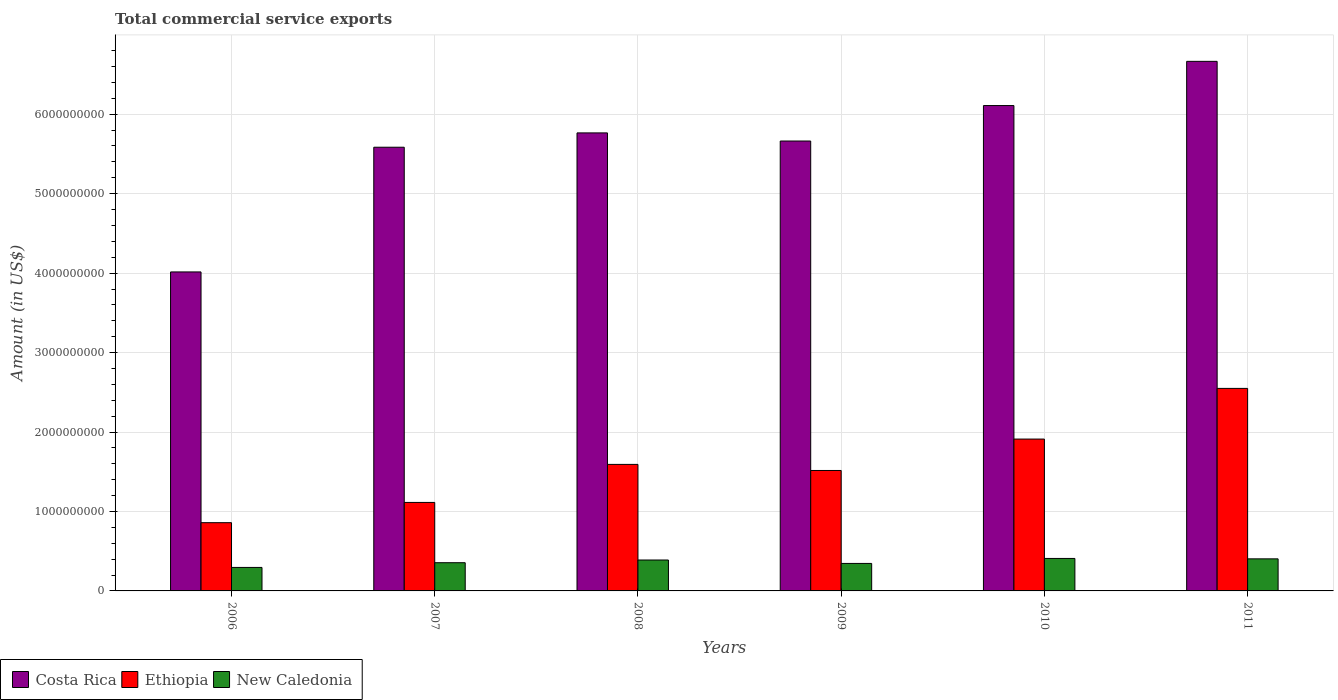How many different coloured bars are there?
Offer a terse response. 3. How many groups of bars are there?
Your response must be concise. 6. How many bars are there on the 4th tick from the left?
Make the answer very short. 3. How many bars are there on the 4th tick from the right?
Your response must be concise. 3. What is the label of the 4th group of bars from the left?
Make the answer very short. 2009. What is the total commercial service exports in Ethiopia in 2011?
Provide a short and direct response. 2.55e+09. Across all years, what is the maximum total commercial service exports in Costa Rica?
Offer a terse response. 6.67e+09. Across all years, what is the minimum total commercial service exports in Costa Rica?
Your answer should be compact. 4.01e+09. In which year was the total commercial service exports in New Caledonia maximum?
Provide a succinct answer. 2010. In which year was the total commercial service exports in Costa Rica minimum?
Keep it short and to the point. 2006. What is the total total commercial service exports in Costa Rica in the graph?
Provide a succinct answer. 3.38e+1. What is the difference between the total commercial service exports in Ethiopia in 2008 and that in 2009?
Provide a short and direct response. 7.64e+07. What is the difference between the total commercial service exports in Costa Rica in 2007 and the total commercial service exports in Ethiopia in 2009?
Provide a short and direct response. 4.07e+09. What is the average total commercial service exports in Costa Rica per year?
Offer a very short reply. 5.63e+09. In the year 2010, what is the difference between the total commercial service exports in New Caledonia and total commercial service exports in Costa Rica?
Provide a succinct answer. -5.70e+09. In how many years, is the total commercial service exports in Ethiopia greater than 400000000 US$?
Provide a succinct answer. 6. What is the ratio of the total commercial service exports in New Caledonia in 2008 to that in 2011?
Give a very brief answer. 0.96. Is the difference between the total commercial service exports in New Caledonia in 2007 and 2010 greater than the difference between the total commercial service exports in Costa Rica in 2007 and 2010?
Provide a succinct answer. Yes. What is the difference between the highest and the second highest total commercial service exports in Costa Rica?
Your answer should be very brief. 5.56e+08. What is the difference between the highest and the lowest total commercial service exports in Costa Rica?
Offer a terse response. 2.65e+09. Is the sum of the total commercial service exports in Ethiopia in 2008 and 2011 greater than the maximum total commercial service exports in Costa Rica across all years?
Make the answer very short. No. What does the 1st bar from the left in 2010 represents?
Ensure brevity in your answer.  Costa Rica. What does the 2nd bar from the right in 2006 represents?
Your answer should be compact. Ethiopia. Is it the case that in every year, the sum of the total commercial service exports in New Caledonia and total commercial service exports in Ethiopia is greater than the total commercial service exports in Costa Rica?
Provide a succinct answer. No. How many bars are there?
Ensure brevity in your answer.  18. Are all the bars in the graph horizontal?
Keep it short and to the point. No. What is the difference between two consecutive major ticks on the Y-axis?
Provide a short and direct response. 1.00e+09. Where does the legend appear in the graph?
Make the answer very short. Bottom left. How many legend labels are there?
Keep it short and to the point. 3. What is the title of the graph?
Provide a short and direct response. Total commercial service exports. Does "Lesotho" appear as one of the legend labels in the graph?
Give a very brief answer. No. What is the Amount (in US$) in Costa Rica in 2006?
Offer a terse response. 4.01e+09. What is the Amount (in US$) in Ethiopia in 2006?
Your response must be concise. 8.59e+08. What is the Amount (in US$) of New Caledonia in 2006?
Provide a succinct answer. 2.96e+08. What is the Amount (in US$) of Costa Rica in 2007?
Keep it short and to the point. 5.58e+09. What is the Amount (in US$) of Ethiopia in 2007?
Make the answer very short. 1.11e+09. What is the Amount (in US$) in New Caledonia in 2007?
Offer a very short reply. 3.55e+08. What is the Amount (in US$) of Costa Rica in 2008?
Offer a very short reply. 5.76e+09. What is the Amount (in US$) in Ethiopia in 2008?
Give a very brief answer. 1.59e+09. What is the Amount (in US$) in New Caledonia in 2008?
Your answer should be very brief. 3.89e+08. What is the Amount (in US$) of Costa Rica in 2009?
Provide a succinct answer. 5.66e+09. What is the Amount (in US$) in Ethiopia in 2009?
Ensure brevity in your answer.  1.52e+09. What is the Amount (in US$) of New Caledonia in 2009?
Ensure brevity in your answer.  3.46e+08. What is the Amount (in US$) in Costa Rica in 2010?
Your response must be concise. 6.11e+09. What is the Amount (in US$) in Ethiopia in 2010?
Your response must be concise. 1.91e+09. What is the Amount (in US$) of New Caledonia in 2010?
Your response must be concise. 4.09e+08. What is the Amount (in US$) of Costa Rica in 2011?
Give a very brief answer. 6.67e+09. What is the Amount (in US$) in Ethiopia in 2011?
Provide a short and direct response. 2.55e+09. What is the Amount (in US$) in New Caledonia in 2011?
Provide a succinct answer. 4.04e+08. Across all years, what is the maximum Amount (in US$) of Costa Rica?
Your answer should be compact. 6.67e+09. Across all years, what is the maximum Amount (in US$) in Ethiopia?
Ensure brevity in your answer.  2.55e+09. Across all years, what is the maximum Amount (in US$) in New Caledonia?
Offer a terse response. 4.09e+08. Across all years, what is the minimum Amount (in US$) in Costa Rica?
Keep it short and to the point. 4.01e+09. Across all years, what is the minimum Amount (in US$) of Ethiopia?
Your answer should be very brief. 8.59e+08. Across all years, what is the minimum Amount (in US$) in New Caledonia?
Your answer should be compact. 2.96e+08. What is the total Amount (in US$) of Costa Rica in the graph?
Keep it short and to the point. 3.38e+1. What is the total Amount (in US$) in Ethiopia in the graph?
Offer a very short reply. 9.54e+09. What is the total Amount (in US$) of New Caledonia in the graph?
Provide a short and direct response. 2.20e+09. What is the difference between the Amount (in US$) of Costa Rica in 2006 and that in 2007?
Ensure brevity in your answer.  -1.57e+09. What is the difference between the Amount (in US$) in Ethiopia in 2006 and that in 2007?
Your response must be concise. -2.55e+08. What is the difference between the Amount (in US$) in New Caledonia in 2006 and that in 2007?
Make the answer very short. -5.93e+07. What is the difference between the Amount (in US$) in Costa Rica in 2006 and that in 2008?
Your answer should be compact. -1.75e+09. What is the difference between the Amount (in US$) of Ethiopia in 2006 and that in 2008?
Keep it short and to the point. -7.34e+08. What is the difference between the Amount (in US$) of New Caledonia in 2006 and that in 2008?
Your answer should be very brief. -9.35e+07. What is the difference between the Amount (in US$) in Costa Rica in 2006 and that in 2009?
Make the answer very short. -1.65e+09. What is the difference between the Amount (in US$) of Ethiopia in 2006 and that in 2009?
Your answer should be compact. -6.57e+08. What is the difference between the Amount (in US$) of New Caledonia in 2006 and that in 2009?
Give a very brief answer. -5.04e+07. What is the difference between the Amount (in US$) of Costa Rica in 2006 and that in 2010?
Provide a succinct answer. -2.09e+09. What is the difference between the Amount (in US$) of Ethiopia in 2006 and that in 2010?
Your answer should be compact. -1.05e+09. What is the difference between the Amount (in US$) in New Caledonia in 2006 and that in 2010?
Ensure brevity in your answer.  -1.13e+08. What is the difference between the Amount (in US$) of Costa Rica in 2006 and that in 2011?
Offer a very short reply. -2.65e+09. What is the difference between the Amount (in US$) of Ethiopia in 2006 and that in 2011?
Ensure brevity in your answer.  -1.69e+09. What is the difference between the Amount (in US$) in New Caledonia in 2006 and that in 2011?
Provide a succinct answer. -1.08e+08. What is the difference between the Amount (in US$) of Costa Rica in 2007 and that in 2008?
Offer a very short reply. -1.80e+08. What is the difference between the Amount (in US$) of Ethiopia in 2007 and that in 2008?
Your answer should be very brief. -4.79e+08. What is the difference between the Amount (in US$) in New Caledonia in 2007 and that in 2008?
Your answer should be compact. -3.42e+07. What is the difference between the Amount (in US$) in Costa Rica in 2007 and that in 2009?
Provide a succinct answer. -7.81e+07. What is the difference between the Amount (in US$) in Ethiopia in 2007 and that in 2009?
Give a very brief answer. -4.02e+08. What is the difference between the Amount (in US$) of New Caledonia in 2007 and that in 2009?
Your answer should be compact. 8.89e+06. What is the difference between the Amount (in US$) in Costa Rica in 2007 and that in 2010?
Your response must be concise. -5.25e+08. What is the difference between the Amount (in US$) in Ethiopia in 2007 and that in 2010?
Make the answer very short. -7.98e+08. What is the difference between the Amount (in US$) in New Caledonia in 2007 and that in 2010?
Make the answer very short. -5.38e+07. What is the difference between the Amount (in US$) of Costa Rica in 2007 and that in 2011?
Keep it short and to the point. -1.08e+09. What is the difference between the Amount (in US$) of Ethiopia in 2007 and that in 2011?
Your response must be concise. -1.44e+09. What is the difference between the Amount (in US$) of New Caledonia in 2007 and that in 2011?
Provide a short and direct response. -4.87e+07. What is the difference between the Amount (in US$) in Costa Rica in 2008 and that in 2009?
Give a very brief answer. 1.02e+08. What is the difference between the Amount (in US$) in Ethiopia in 2008 and that in 2009?
Your response must be concise. 7.64e+07. What is the difference between the Amount (in US$) of New Caledonia in 2008 and that in 2009?
Ensure brevity in your answer.  4.31e+07. What is the difference between the Amount (in US$) in Costa Rica in 2008 and that in 2010?
Keep it short and to the point. -3.44e+08. What is the difference between the Amount (in US$) of Ethiopia in 2008 and that in 2010?
Provide a short and direct response. -3.19e+08. What is the difference between the Amount (in US$) of New Caledonia in 2008 and that in 2010?
Your answer should be compact. -1.97e+07. What is the difference between the Amount (in US$) in Costa Rica in 2008 and that in 2011?
Offer a very short reply. -9.01e+08. What is the difference between the Amount (in US$) in Ethiopia in 2008 and that in 2011?
Your response must be concise. -9.56e+08. What is the difference between the Amount (in US$) of New Caledonia in 2008 and that in 2011?
Offer a terse response. -1.45e+07. What is the difference between the Amount (in US$) of Costa Rica in 2009 and that in 2010?
Keep it short and to the point. -4.46e+08. What is the difference between the Amount (in US$) of Ethiopia in 2009 and that in 2010?
Your answer should be very brief. -3.95e+08. What is the difference between the Amount (in US$) in New Caledonia in 2009 and that in 2010?
Give a very brief answer. -6.27e+07. What is the difference between the Amount (in US$) of Costa Rica in 2009 and that in 2011?
Your response must be concise. -1.00e+09. What is the difference between the Amount (in US$) of Ethiopia in 2009 and that in 2011?
Provide a short and direct response. -1.03e+09. What is the difference between the Amount (in US$) in New Caledonia in 2009 and that in 2011?
Ensure brevity in your answer.  -5.76e+07. What is the difference between the Amount (in US$) in Costa Rica in 2010 and that in 2011?
Make the answer very short. -5.56e+08. What is the difference between the Amount (in US$) in Ethiopia in 2010 and that in 2011?
Offer a very short reply. -6.38e+08. What is the difference between the Amount (in US$) in New Caledonia in 2010 and that in 2011?
Make the answer very short. 5.13e+06. What is the difference between the Amount (in US$) of Costa Rica in 2006 and the Amount (in US$) of Ethiopia in 2007?
Your answer should be very brief. 2.90e+09. What is the difference between the Amount (in US$) in Costa Rica in 2006 and the Amount (in US$) in New Caledonia in 2007?
Make the answer very short. 3.66e+09. What is the difference between the Amount (in US$) of Ethiopia in 2006 and the Amount (in US$) of New Caledonia in 2007?
Your response must be concise. 5.04e+08. What is the difference between the Amount (in US$) of Costa Rica in 2006 and the Amount (in US$) of Ethiopia in 2008?
Offer a terse response. 2.42e+09. What is the difference between the Amount (in US$) in Costa Rica in 2006 and the Amount (in US$) in New Caledonia in 2008?
Provide a succinct answer. 3.63e+09. What is the difference between the Amount (in US$) in Ethiopia in 2006 and the Amount (in US$) in New Caledonia in 2008?
Keep it short and to the point. 4.70e+08. What is the difference between the Amount (in US$) of Costa Rica in 2006 and the Amount (in US$) of Ethiopia in 2009?
Keep it short and to the point. 2.50e+09. What is the difference between the Amount (in US$) of Costa Rica in 2006 and the Amount (in US$) of New Caledonia in 2009?
Offer a terse response. 3.67e+09. What is the difference between the Amount (in US$) in Ethiopia in 2006 and the Amount (in US$) in New Caledonia in 2009?
Provide a short and direct response. 5.13e+08. What is the difference between the Amount (in US$) of Costa Rica in 2006 and the Amount (in US$) of Ethiopia in 2010?
Provide a succinct answer. 2.10e+09. What is the difference between the Amount (in US$) of Costa Rica in 2006 and the Amount (in US$) of New Caledonia in 2010?
Make the answer very short. 3.61e+09. What is the difference between the Amount (in US$) of Ethiopia in 2006 and the Amount (in US$) of New Caledonia in 2010?
Offer a very short reply. 4.50e+08. What is the difference between the Amount (in US$) of Costa Rica in 2006 and the Amount (in US$) of Ethiopia in 2011?
Your answer should be very brief. 1.47e+09. What is the difference between the Amount (in US$) in Costa Rica in 2006 and the Amount (in US$) in New Caledonia in 2011?
Provide a succinct answer. 3.61e+09. What is the difference between the Amount (in US$) of Ethiopia in 2006 and the Amount (in US$) of New Caledonia in 2011?
Your answer should be compact. 4.55e+08. What is the difference between the Amount (in US$) of Costa Rica in 2007 and the Amount (in US$) of Ethiopia in 2008?
Your response must be concise. 3.99e+09. What is the difference between the Amount (in US$) of Costa Rica in 2007 and the Amount (in US$) of New Caledonia in 2008?
Your answer should be compact. 5.20e+09. What is the difference between the Amount (in US$) in Ethiopia in 2007 and the Amount (in US$) in New Caledonia in 2008?
Your response must be concise. 7.25e+08. What is the difference between the Amount (in US$) in Costa Rica in 2007 and the Amount (in US$) in Ethiopia in 2009?
Give a very brief answer. 4.07e+09. What is the difference between the Amount (in US$) in Costa Rica in 2007 and the Amount (in US$) in New Caledonia in 2009?
Provide a short and direct response. 5.24e+09. What is the difference between the Amount (in US$) in Ethiopia in 2007 and the Amount (in US$) in New Caledonia in 2009?
Provide a succinct answer. 7.68e+08. What is the difference between the Amount (in US$) in Costa Rica in 2007 and the Amount (in US$) in Ethiopia in 2010?
Give a very brief answer. 3.67e+09. What is the difference between the Amount (in US$) in Costa Rica in 2007 and the Amount (in US$) in New Caledonia in 2010?
Ensure brevity in your answer.  5.18e+09. What is the difference between the Amount (in US$) in Ethiopia in 2007 and the Amount (in US$) in New Caledonia in 2010?
Ensure brevity in your answer.  7.05e+08. What is the difference between the Amount (in US$) in Costa Rica in 2007 and the Amount (in US$) in Ethiopia in 2011?
Offer a terse response. 3.04e+09. What is the difference between the Amount (in US$) of Costa Rica in 2007 and the Amount (in US$) of New Caledonia in 2011?
Offer a very short reply. 5.18e+09. What is the difference between the Amount (in US$) in Ethiopia in 2007 and the Amount (in US$) in New Caledonia in 2011?
Make the answer very short. 7.10e+08. What is the difference between the Amount (in US$) of Costa Rica in 2008 and the Amount (in US$) of Ethiopia in 2009?
Provide a succinct answer. 4.25e+09. What is the difference between the Amount (in US$) in Costa Rica in 2008 and the Amount (in US$) in New Caledonia in 2009?
Offer a very short reply. 5.42e+09. What is the difference between the Amount (in US$) in Ethiopia in 2008 and the Amount (in US$) in New Caledonia in 2009?
Your answer should be compact. 1.25e+09. What is the difference between the Amount (in US$) of Costa Rica in 2008 and the Amount (in US$) of Ethiopia in 2010?
Your response must be concise. 3.85e+09. What is the difference between the Amount (in US$) in Costa Rica in 2008 and the Amount (in US$) in New Caledonia in 2010?
Provide a short and direct response. 5.36e+09. What is the difference between the Amount (in US$) in Ethiopia in 2008 and the Amount (in US$) in New Caledonia in 2010?
Give a very brief answer. 1.18e+09. What is the difference between the Amount (in US$) of Costa Rica in 2008 and the Amount (in US$) of Ethiopia in 2011?
Provide a short and direct response. 3.22e+09. What is the difference between the Amount (in US$) in Costa Rica in 2008 and the Amount (in US$) in New Caledonia in 2011?
Give a very brief answer. 5.36e+09. What is the difference between the Amount (in US$) of Ethiopia in 2008 and the Amount (in US$) of New Caledonia in 2011?
Offer a terse response. 1.19e+09. What is the difference between the Amount (in US$) in Costa Rica in 2009 and the Amount (in US$) in Ethiopia in 2010?
Your answer should be very brief. 3.75e+09. What is the difference between the Amount (in US$) of Costa Rica in 2009 and the Amount (in US$) of New Caledonia in 2010?
Give a very brief answer. 5.25e+09. What is the difference between the Amount (in US$) of Ethiopia in 2009 and the Amount (in US$) of New Caledonia in 2010?
Your answer should be very brief. 1.11e+09. What is the difference between the Amount (in US$) of Costa Rica in 2009 and the Amount (in US$) of Ethiopia in 2011?
Make the answer very short. 3.11e+09. What is the difference between the Amount (in US$) in Costa Rica in 2009 and the Amount (in US$) in New Caledonia in 2011?
Your answer should be very brief. 5.26e+09. What is the difference between the Amount (in US$) in Ethiopia in 2009 and the Amount (in US$) in New Caledonia in 2011?
Keep it short and to the point. 1.11e+09. What is the difference between the Amount (in US$) in Costa Rica in 2010 and the Amount (in US$) in Ethiopia in 2011?
Make the answer very short. 3.56e+09. What is the difference between the Amount (in US$) of Costa Rica in 2010 and the Amount (in US$) of New Caledonia in 2011?
Offer a terse response. 5.71e+09. What is the difference between the Amount (in US$) of Ethiopia in 2010 and the Amount (in US$) of New Caledonia in 2011?
Give a very brief answer. 1.51e+09. What is the average Amount (in US$) of Costa Rica per year?
Provide a short and direct response. 5.63e+09. What is the average Amount (in US$) in Ethiopia per year?
Provide a succinct answer. 1.59e+09. What is the average Amount (in US$) in New Caledonia per year?
Offer a terse response. 3.66e+08. In the year 2006, what is the difference between the Amount (in US$) of Costa Rica and Amount (in US$) of Ethiopia?
Ensure brevity in your answer.  3.16e+09. In the year 2006, what is the difference between the Amount (in US$) of Costa Rica and Amount (in US$) of New Caledonia?
Provide a succinct answer. 3.72e+09. In the year 2006, what is the difference between the Amount (in US$) in Ethiopia and Amount (in US$) in New Caledonia?
Offer a terse response. 5.63e+08. In the year 2007, what is the difference between the Amount (in US$) in Costa Rica and Amount (in US$) in Ethiopia?
Provide a short and direct response. 4.47e+09. In the year 2007, what is the difference between the Amount (in US$) in Costa Rica and Amount (in US$) in New Caledonia?
Give a very brief answer. 5.23e+09. In the year 2007, what is the difference between the Amount (in US$) in Ethiopia and Amount (in US$) in New Caledonia?
Your response must be concise. 7.59e+08. In the year 2008, what is the difference between the Amount (in US$) in Costa Rica and Amount (in US$) in Ethiopia?
Your answer should be compact. 4.17e+09. In the year 2008, what is the difference between the Amount (in US$) of Costa Rica and Amount (in US$) of New Caledonia?
Offer a very short reply. 5.38e+09. In the year 2008, what is the difference between the Amount (in US$) of Ethiopia and Amount (in US$) of New Caledonia?
Keep it short and to the point. 1.20e+09. In the year 2009, what is the difference between the Amount (in US$) of Costa Rica and Amount (in US$) of Ethiopia?
Ensure brevity in your answer.  4.15e+09. In the year 2009, what is the difference between the Amount (in US$) in Costa Rica and Amount (in US$) in New Caledonia?
Provide a short and direct response. 5.32e+09. In the year 2009, what is the difference between the Amount (in US$) of Ethiopia and Amount (in US$) of New Caledonia?
Offer a terse response. 1.17e+09. In the year 2010, what is the difference between the Amount (in US$) of Costa Rica and Amount (in US$) of Ethiopia?
Give a very brief answer. 4.20e+09. In the year 2010, what is the difference between the Amount (in US$) of Costa Rica and Amount (in US$) of New Caledonia?
Ensure brevity in your answer.  5.70e+09. In the year 2010, what is the difference between the Amount (in US$) in Ethiopia and Amount (in US$) in New Caledonia?
Offer a terse response. 1.50e+09. In the year 2011, what is the difference between the Amount (in US$) of Costa Rica and Amount (in US$) of Ethiopia?
Keep it short and to the point. 4.12e+09. In the year 2011, what is the difference between the Amount (in US$) of Costa Rica and Amount (in US$) of New Caledonia?
Make the answer very short. 6.26e+09. In the year 2011, what is the difference between the Amount (in US$) in Ethiopia and Amount (in US$) in New Caledonia?
Ensure brevity in your answer.  2.15e+09. What is the ratio of the Amount (in US$) in Costa Rica in 2006 to that in 2007?
Your answer should be compact. 0.72. What is the ratio of the Amount (in US$) of Ethiopia in 2006 to that in 2007?
Ensure brevity in your answer.  0.77. What is the ratio of the Amount (in US$) of New Caledonia in 2006 to that in 2007?
Provide a short and direct response. 0.83. What is the ratio of the Amount (in US$) of Costa Rica in 2006 to that in 2008?
Ensure brevity in your answer.  0.7. What is the ratio of the Amount (in US$) of Ethiopia in 2006 to that in 2008?
Give a very brief answer. 0.54. What is the ratio of the Amount (in US$) of New Caledonia in 2006 to that in 2008?
Provide a succinct answer. 0.76. What is the ratio of the Amount (in US$) in Costa Rica in 2006 to that in 2009?
Your response must be concise. 0.71. What is the ratio of the Amount (in US$) of Ethiopia in 2006 to that in 2009?
Your answer should be very brief. 0.57. What is the ratio of the Amount (in US$) of New Caledonia in 2006 to that in 2009?
Keep it short and to the point. 0.85. What is the ratio of the Amount (in US$) in Costa Rica in 2006 to that in 2010?
Offer a very short reply. 0.66. What is the ratio of the Amount (in US$) in Ethiopia in 2006 to that in 2010?
Keep it short and to the point. 0.45. What is the ratio of the Amount (in US$) in New Caledonia in 2006 to that in 2010?
Offer a terse response. 0.72. What is the ratio of the Amount (in US$) of Costa Rica in 2006 to that in 2011?
Give a very brief answer. 0.6. What is the ratio of the Amount (in US$) in Ethiopia in 2006 to that in 2011?
Give a very brief answer. 0.34. What is the ratio of the Amount (in US$) in New Caledonia in 2006 to that in 2011?
Provide a succinct answer. 0.73. What is the ratio of the Amount (in US$) in Costa Rica in 2007 to that in 2008?
Give a very brief answer. 0.97. What is the ratio of the Amount (in US$) in Ethiopia in 2007 to that in 2008?
Your response must be concise. 0.7. What is the ratio of the Amount (in US$) of New Caledonia in 2007 to that in 2008?
Ensure brevity in your answer.  0.91. What is the ratio of the Amount (in US$) in Costa Rica in 2007 to that in 2009?
Give a very brief answer. 0.99. What is the ratio of the Amount (in US$) of Ethiopia in 2007 to that in 2009?
Offer a terse response. 0.73. What is the ratio of the Amount (in US$) of New Caledonia in 2007 to that in 2009?
Offer a terse response. 1.03. What is the ratio of the Amount (in US$) in Costa Rica in 2007 to that in 2010?
Give a very brief answer. 0.91. What is the ratio of the Amount (in US$) of Ethiopia in 2007 to that in 2010?
Ensure brevity in your answer.  0.58. What is the ratio of the Amount (in US$) in New Caledonia in 2007 to that in 2010?
Provide a short and direct response. 0.87. What is the ratio of the Amount (in US$) in Costa Rica in 2007 to that in 2011?
Your answer should be very brief. 0.84. What is the ratio of the Amount (in US$) in Ethiopia in 2007 to that in 2011?
Your response must be concise. 0.44. What is the ratio of the Amount (in US$) of New Caledonia in 2007 to that in 2011?
Your answer should be very brief. 0.88. What is the ratio of the Amount (in US$) in Costa Rica in 2008 to that in 2009?
Your answer should be very brief. 1.02. What is the ratio of the Amount (in US$) in Ethiopia in 2008 to that in 2009?
Make the answer very short. 1.05. What is the ratio of the Amount (in US$) in New Caledonia in 2008 to that in 2009?
Your answer should be compact. 1.12. What is the ratio of the Amount (in US$) in Costa Rica in 2008 to that in 2010?
Your answer should be very brief. 0.94. What is the ratio of the Amount (in US$) in Ethiopia in 2008 to that in 2010?
Your answer should be very brief. 0.83. What is the ratio of the Amount (in US$) in New Caledonia in 2008 to that in 2010?
Provide a short and direct response. 0.95. What is the ratio of the Amount (in US$) in Costa Rica in 2008 to that in 2011?
Provide a short and direct response. 0.86. What is the ratio of the Amount (in US$) in Ethiopia in 2008 to that in 2011?
Offer a very short reply. 0.62. What is the ratio of the Amount (in US$) of Costa Rica in 2009 to that in 2010?
Make the answer very short. 0.93. What is the ratio of the Amount (in US$) of Ethiopia in 2009 to that in 2010?
Make the answer very short. 0.79. What is the ratio of the Amount (in US$) in New Caledonia in 2009 to that in 2010?
Make the answer very short. 0.85. What is the ratio of the Amount (in US$) in Costa Rica in 2009 to that in 2011?
Make the answer very short. 0.85. What is the ratio of the Amount (in US$) in Ethiopia in 2009 to that in 2011?
Keep it short and to the point. 0.59. What is the ratio of the Amount (in US$) in New Caledonia in 2009 to that in 2011?
Offer a very short reply. 0.86. What is the ratio of the Amount (in US$) in Costa Rica in 2010 to that in 2011?
Make the answer very short. 0.92. What is the ratio of the Amount (in US$) of Ethiopia in 2010 to that in 2011?
Your answer should be compact. 0.75. What is the ratio of the Amount (in US$) of New Caledonia in 2010 to that in 2011?
Your answer should be very brief. 1.01. What is the difference between the highest and the second highest Amount (in US$) in Costa Rica?
Keep it short and to the point. 5.56e+08. What is the difference between the highest and the second highest Amount (in US$) in Ethiopia?
Provide a succinct answer. 6.38e+08. What is the difference between the highest and the second highest Amount (in US$) in New Caledonia?
Your response must be concise. 5.13e+06. What is the difference between the highest and the lowest Amount (in US$) in Costa Rica?
Keep it short and to the point. 2.65e+09. What is the difference between the highest and the lowest Amount (in US$) in Ethiopia?
Provide a succinct answer. 1.69e+09. What is the difference between the highest and the lowest Amount (in US$) in New Caledonia?
Your response must be concise. 1.13e+08. 